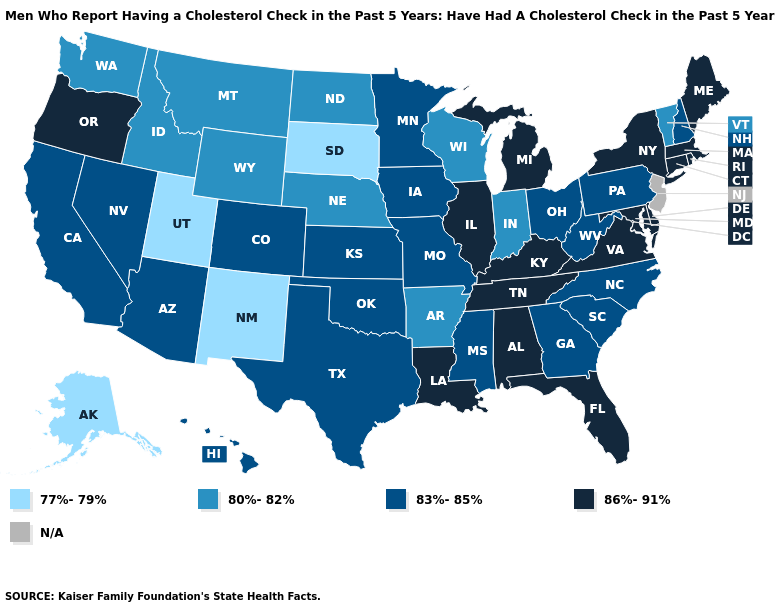Name the states that have a value in the range 86%-91%?
Quick response, please. Alabama, Connecticut, Delaware, Florida, Illinois, Kentucky, Louisiana, Maine, Maryland, Massachusetts, Michigan, New York, Oregon, Rhode Island, Tennessee, Virginia. Among the states that border Ohio , does Michigan have the highest value?
Answer briefly. Yes. What is the highest value in states that border Connecticut?
Short answer required. 86%-91%. Does Alaska have the lowest value in the West?
Quick response, please. Yes. Does the first symbol in the legend represent the smallest category?
Be succinct. Yes. What is the value of Nebraska?
Concise answer only. 80%-82%. Which states have the highest value in the USA?
Give a very brief answer. Alabama, Connecticut, Delaware, Florida, Illinois, Kentucky, Louisiana, Maine, Maryland, Massachusetts, Michigan, New York, Oregon, Rhode Island, Tennessee, Virginia. Which states have the lowest value in the Northeast?
Short answer required. Vermont. What is the value of Minnesota?
Answer briefly. 83%-85%. Does South Dakota have the lowest value in the USA?
Concise answer only. Yes. Name the states that have a value in the range 80%-82%?
Be succinct. Arkansas, Idaho, Indiana, Montana, Nebraska, North Dakota, Vermont, Washington, Wisconsin, Wyoming. Name the states that have a value in the range 83%-85%?
Write a very short answer. Arizona, California, Colorado, Georgia, Hawaii, Iowa, Kansas, Minnesota, Mississippi, Missouri, Nevada, New Hampshire, North Carolina, Ohio, Oklahoma, Pennsylvania, South Carolina, Texas, West Virginia. What is the value of Illinois?
Short answer required. 86%-91%. 